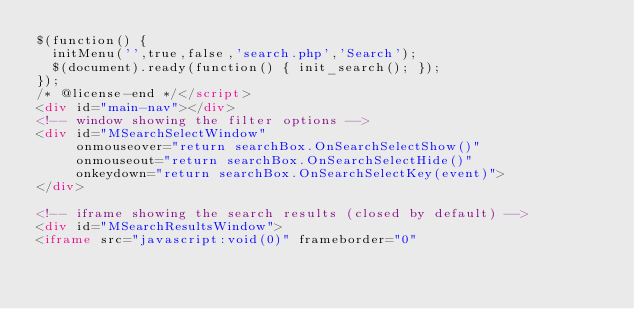Convert code to text. <code><loc_0><loc_0><loc_500><loc_500><_HTML_>$(function() {
  initMenu('',true,false,'search.php','Search');
  $(document).ready(function() { init_search(); });
});
/* @license-end */</script>
<div id="main-nav"></div>
<!-- window showing the filter options -->
<div id="MSearchSelectWindow"
     onmouseover="return searchBox.OnSearchSelectShow()"
     onmouseout="return searchBox.OnSearchSelectHide()"
     onkeydown="return searchBox.OnSearchSelectKey(event)">
</div>

<!-- iframe showing the search results (closed by default) -->
<div id="MSearchResultsWindow">
<iframe src="javascript:void(0)" frameborder="0" </code> 